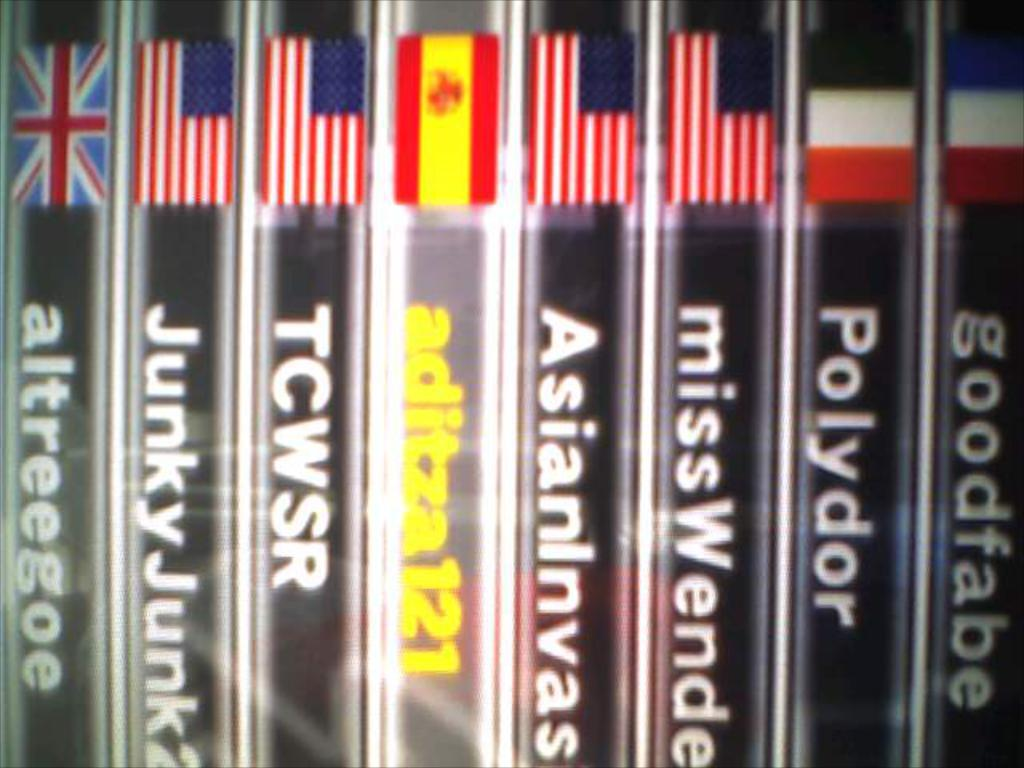<image>
Render a clear and concise summary of the photo. A collection of British and American movies sit on a shelf one called Junky Junk 2 